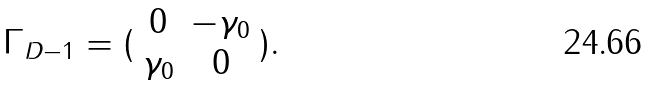Convert formula to latex. <formula><loc_0><loc_0><loc_500><loc_500>\Gamma _ { D - 1 } = ( \begin{array} { c c } 0 & - \gamma _ { 0 } \\ \gamma _ { 0 } & 0 \end{array} ) .</formula> 